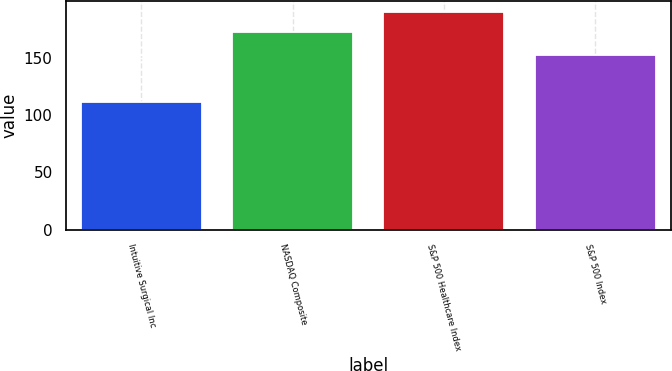Convert chart. <chart><loc_0><loc_0><loc_500><loc_500><bar_chart><fcel>Intuitive Surgical Inc<fcel>NASDAQ Composite<fcel>S&P 500 Healthcare Index<fcel>S&P 500 Index<nl><fcel>111.38<fcel>171.97<fcel>189.52<fcel>152.59<nl></chart> 